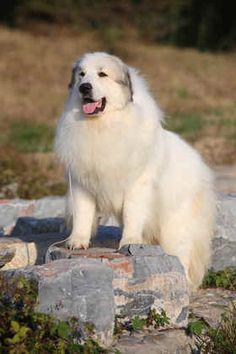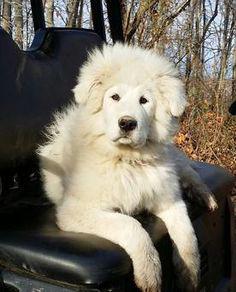The first image is the image on the left, the second image is the image on the right. Examine the images to the left and right. Is the description "There are at most two dogs." accurate? Answer yes or no. Yes. The first image is the image on the left, the second image is the image on the right. Given the left and right images, does the statement "One image shows a single sitting white dog, and the other image contains multiple white dogs that are all puppies." hold true? Answer yes or no. No. 